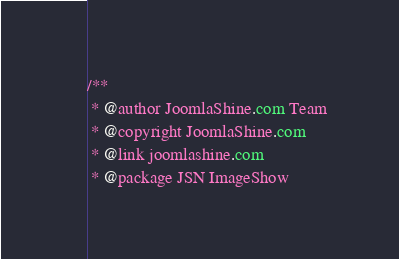<code> <loc_0><loc_0><loc_500><loc_500><_CSS_>/**
 * @author JoomlaShine.com Team
 * @copyright JoomlaShine.com
 * @link joomlashine.com
 * @package JSN ImageShow</code> 